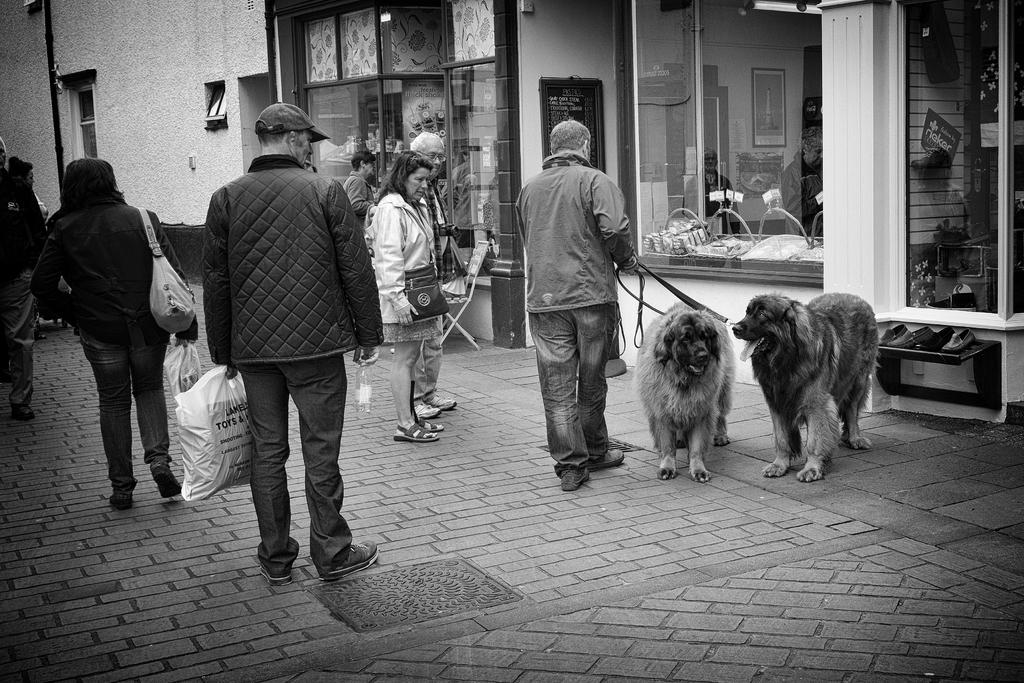How many people are present in the image? There are four persons standing on the road in the image. What other living creatures can be seen in the image? There are dogs in the image. What can be seen in the background of the image? There is a building in the background of the image. Are there any openings in the building visible in the image? Yes, there is a door and a window in the image. Where is the kettle located in the image? There is no kettle present in the image. What type of show can be seen taking place in the image? There is no show or performance depicted in the image. 